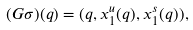Convert formula to latex. <formula><loc_0><loc_0><loc_500><loc_500>( G \sigma ) ( q ) = ( q , x ^ { u } _ { 1 } ( q ) , x ^ { s } _ { 1 } ( q ) ) ,</formula> 